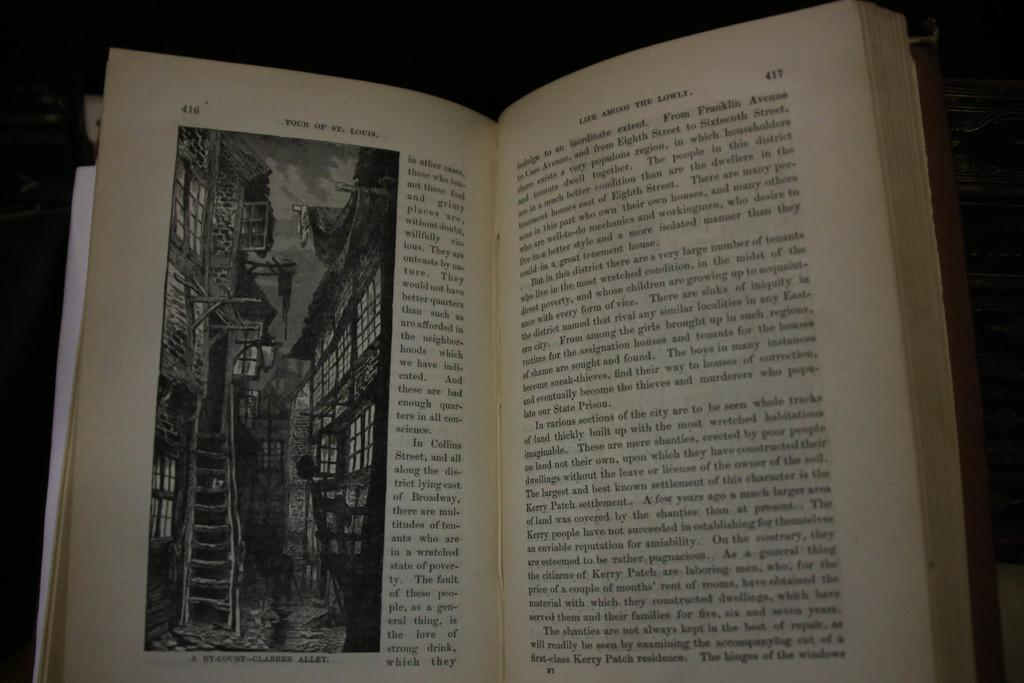What is the main object in the image? There is a book with papers in the image. What can be seen on the paper? There is a picture and letters on the paper. Can you describe the background of the image? The background of the image appears dark. Where is the kitty playing in the garden in the image? There is no kitty or garden present in the image; it features a book with papers and a dark background. 